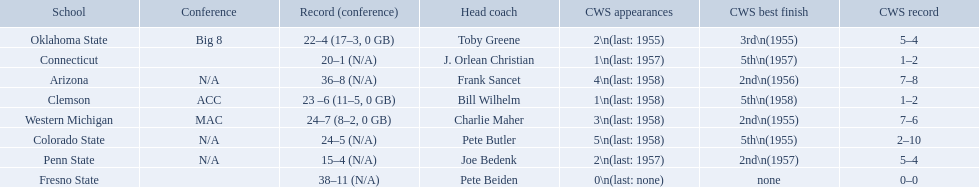What was the least amount of wins recorded by the losingest team? 15–4 (N/A). Parse the table in full. {'header': ['School', 'Conference', 'Record (conference)', 'Head coach', 'CWS appearances', 'CWS best finish', 'CWS record'], 'rows': [['Oklahoma State', 'Big 8', '22–4 (17–3, 0 GB)', 'Toby Greene', '2\\n(last: 1955)', '3rd\\n(1955)', '5–4'], ['Connecticut', '', '20–1 (N/A)', 'J. Orlean Christian', '1\\n(last: 1957)', '5th\\n(1957)', '1–2'], ['Arizona', 'N/A', '36–8 (N/A)', 'Frank Sancet', '4\\n(last: 1958)', '2nd\\n(1956)', '7–8'], ['Clemson', 'ACC', '23 –6 (11–5, 0 GB)', 'Bill Wilhelm', '1\\n(last: 1958)', '5th\\n(1958)', '1–2'], ['Western Michigan', 'MAC', '24–7 (8–2, 0 GB)', 'Charlie Maher', '3\\n(last: 1958)', '2nd\\n(1955)', '7–6'], ['Colorado State', 'N/A', '24–5 (N/A)', 'Pete Butler', '5\\n(last: 1958)', '5th\\n(1955)', '2–10'], ['Penn State', 'N/A', '15–4 (N/A)', 'Joe Bedenk', '2\\n(last: 1957)', '2nd\\n(1957)', '5–4'], ['Fresno State', '', '38–11 (N/A)', 'Pete Beiden', '0\\n(last: none)', 'none', '0–0']]} Which team held this record? Penn State. Could you parse the entire table as a dict? {'header': ['School', 'Conference', 'Record (conference)', 'Head coach', 'CWS appearances', 'CWS best finish', 'CWS record'], 'rows': [['Oklahoma State', 'Big 8', '22–4 (17–3, 0 GB)', 'Toby Greene', '2\\n(last: 1955)', '3rd\\n(1955)', '5–4'], ['Connecticut', '', '20–1 (N/A)', 'J. Orlean Christian', '1\\n(last: 1957)', '5th\\n(1957)', '1–2'], ['Arizona', 'N/A', '36–8 (N/A)', 'Frank Sancet', '4\\n(last: 1958)', '2nd\\n(1956)', '7–8'], ['Clemson', 'ACC', '23 –6 (11–5, 0 GB)', 'Bill Wilhelm', '1\\n(last: 1958)', '5th\\n(1958)', '1–2'], ['Western Michigan', 'MAC', '24–7 (8–2, 0 GB)', 'Charlie Maher', '3\\n(last: 1958)', '2nd\\n(1955)', '7–6'], ['Colorado State', 'N/A', '24–5 (N/A)', 'Pete Butler', '5\\n(last: 1958)', '5th\\n(1955)', '2–10'], ['Penn State', 'N/A', '15–4 (N/A)', 'Joe Bedenk', '2\\n(last: 1957)', '2nd\\n(1957)', '5–4'], ['Fresno State', '', '38–11 (N/A)', 'Pete Beiden', '0\\n(last: none)', 'none', '0–0']]} What were scores for each school in the 1959 ncaa tournament? 36–8 (N/A), 23 –6 (11–5, 0 GB), 24–5 (N/A), 20–1 (N/A), 38–11 (N/A), 22–4 (17–3, 0 GB), 15–4 (N/A), 24–7 (8–2, 0 GB). What score did not have at least 16 wins? 15–4 (N/A). What team earned this score? Penn State. What are the teams in the conference? Arizona, Clemson, Colorado State, Connecticut, Fresno State, Oklahoma State, Penn State, Western Michigan. Which have more than 16 wins? Arizona, Clemson, Colorado State, Connecticut, Fresno State, Oklahoma State, Western Michigan. Which had less than 16 wins? Penn State. 